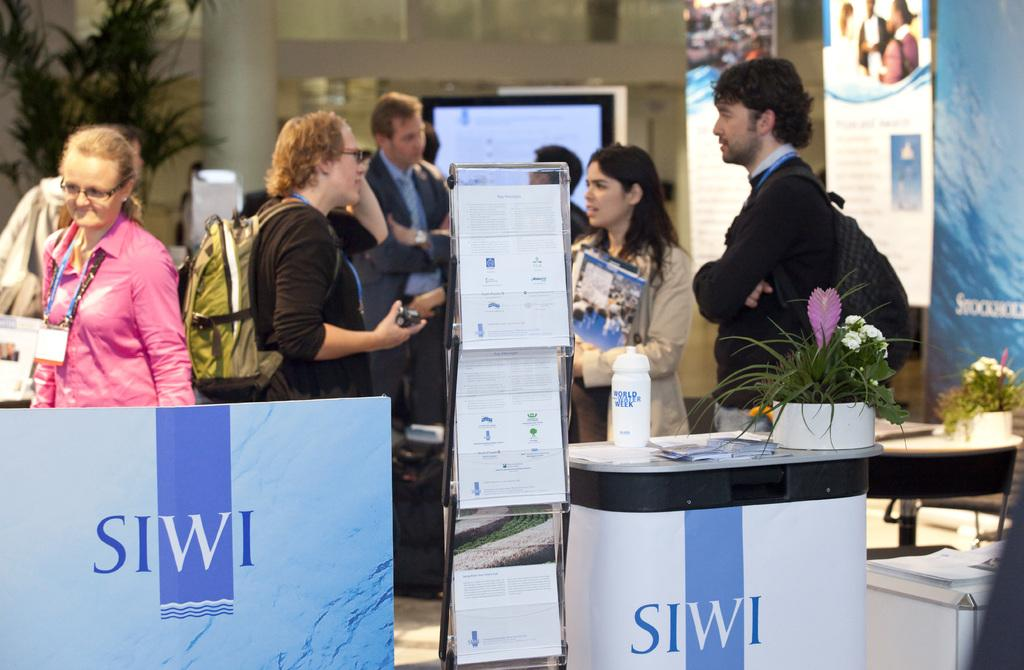<image>
Render a clear and concise summary of the photo. The SIWI logo can be seen in a room with several people. 